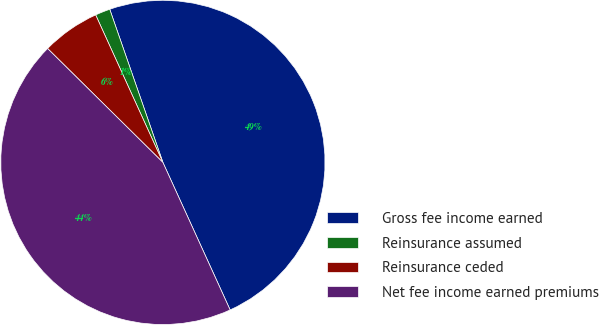Convert chart. <chart><loc_0><loc_0><loc_500><loc_500><pie_chart><fcel>Gross fee income earned<fcel>Reinsurance assumed<fcel>Reinsurance ceded<fcel>Net fee income earned premiums<nl><fcel>48.51%<fcel>1.49%<fcel>5.79%<fcel>44.21%<nl></chart> 